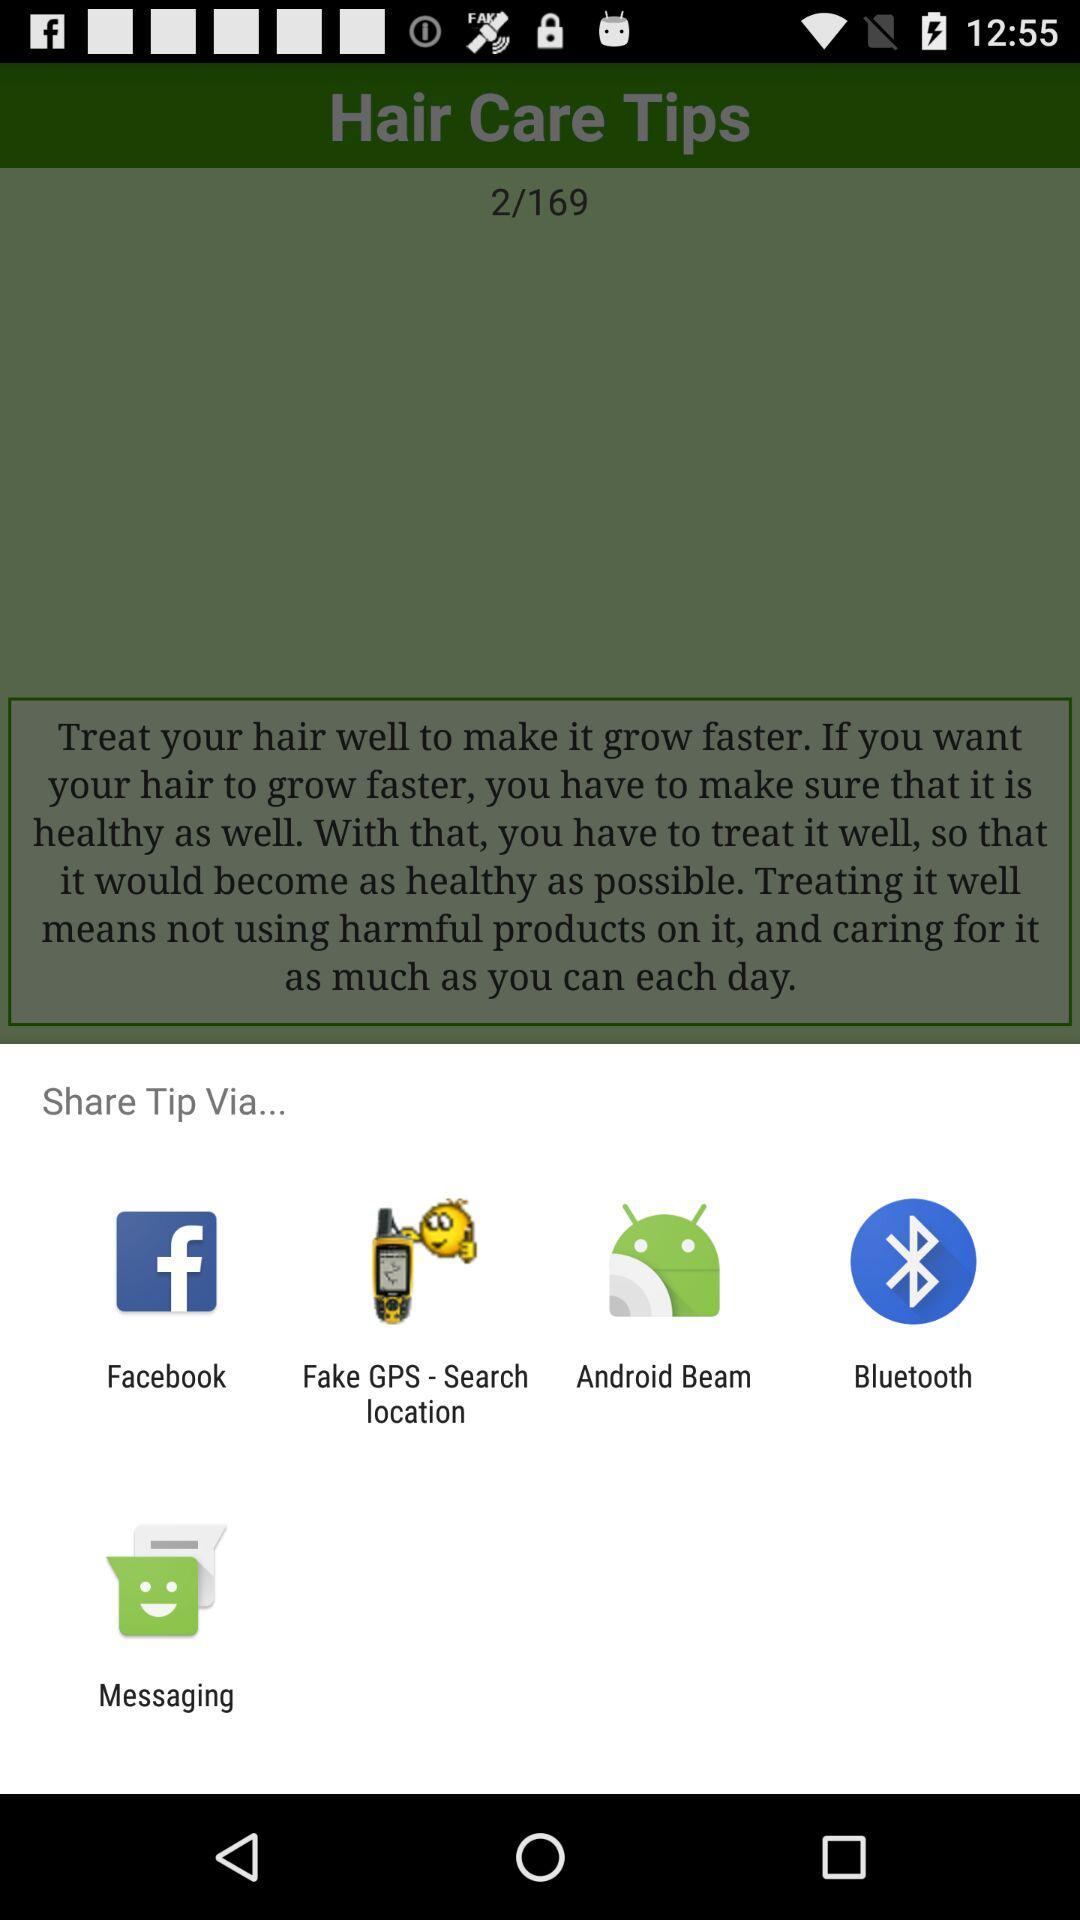How many weeks will it take to make my hair grow faster?
When the provided information is insufficient, respond with <no answer>. <no answer> 